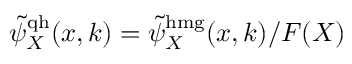Convert formula to latex. <formula><loc_0><loc_0><loc_500><loc_500>\tilde { \psi } _ { X } ^ { q h } ( x , k ) = \tilde { \psi } _ { X } ^ { h m g } ( x , k ) / F ( X )</formula> 